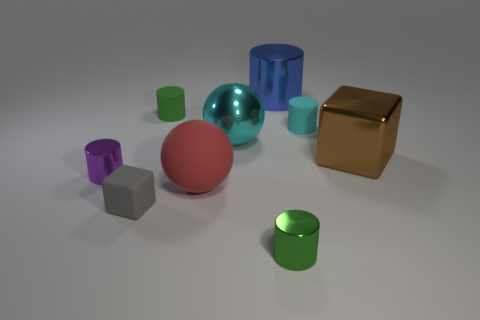How many other things are there of the same size as the gray cube? In the image, there appears to be one object that closely matches the size of the gray cube, which is the small purple cube. The other objects vary in size and shape, such as the larger cubes, cylindrical shapes, and spheres, making them not quite the same size as the referenced gray cube. 